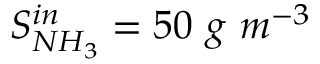<formula> <loc_0><loc_0><loc_500><loc_500>S _ { N H _ { 3 } } ^ { i n } = 5 0 \ g \ m ^ { - 3 }</formula> 